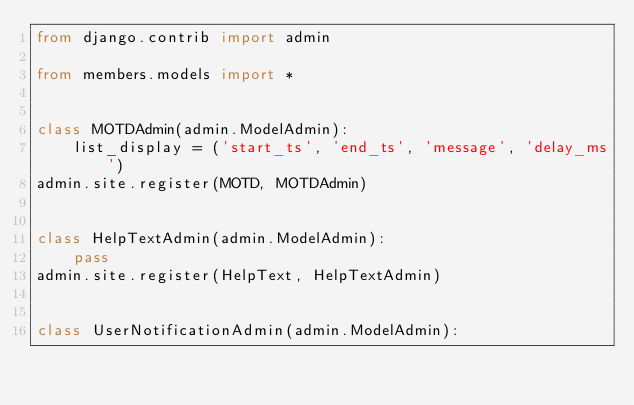Convert code to text. <code><loc_0><loc_0><loc_500><loc_500><_Python_>from django.contrib import admin

from members.models import *


class MOTDAdmin(admin.ModelAdmin):
    list_display = ('start_ts', 'end_ts', 'message', 'delay_ms')
admin.site.register(MOTD, MOTDAdmin)


class HelpTextAdmin(admin.ModelAdmin):
    pass
admin.site.register(HelpText, HelpTextAdmin)


class UserNotificationAdmin(admin.ModelAdmin):</code> 